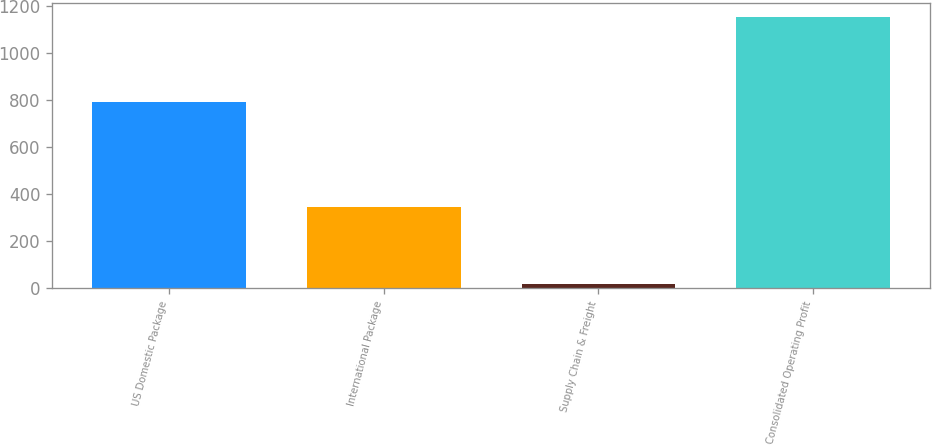Convert chart. <chart><loc_0><loc_0><loc_500><loc_500><bar_chart><fcel>US Domestic Package<fcel>International Package<fcel>Supply Chain & Freight<fcel>Consolidated Operating Profit<nl><fcel>791<fcel>345<fcel>18<fcel>1154<nl></chart> 